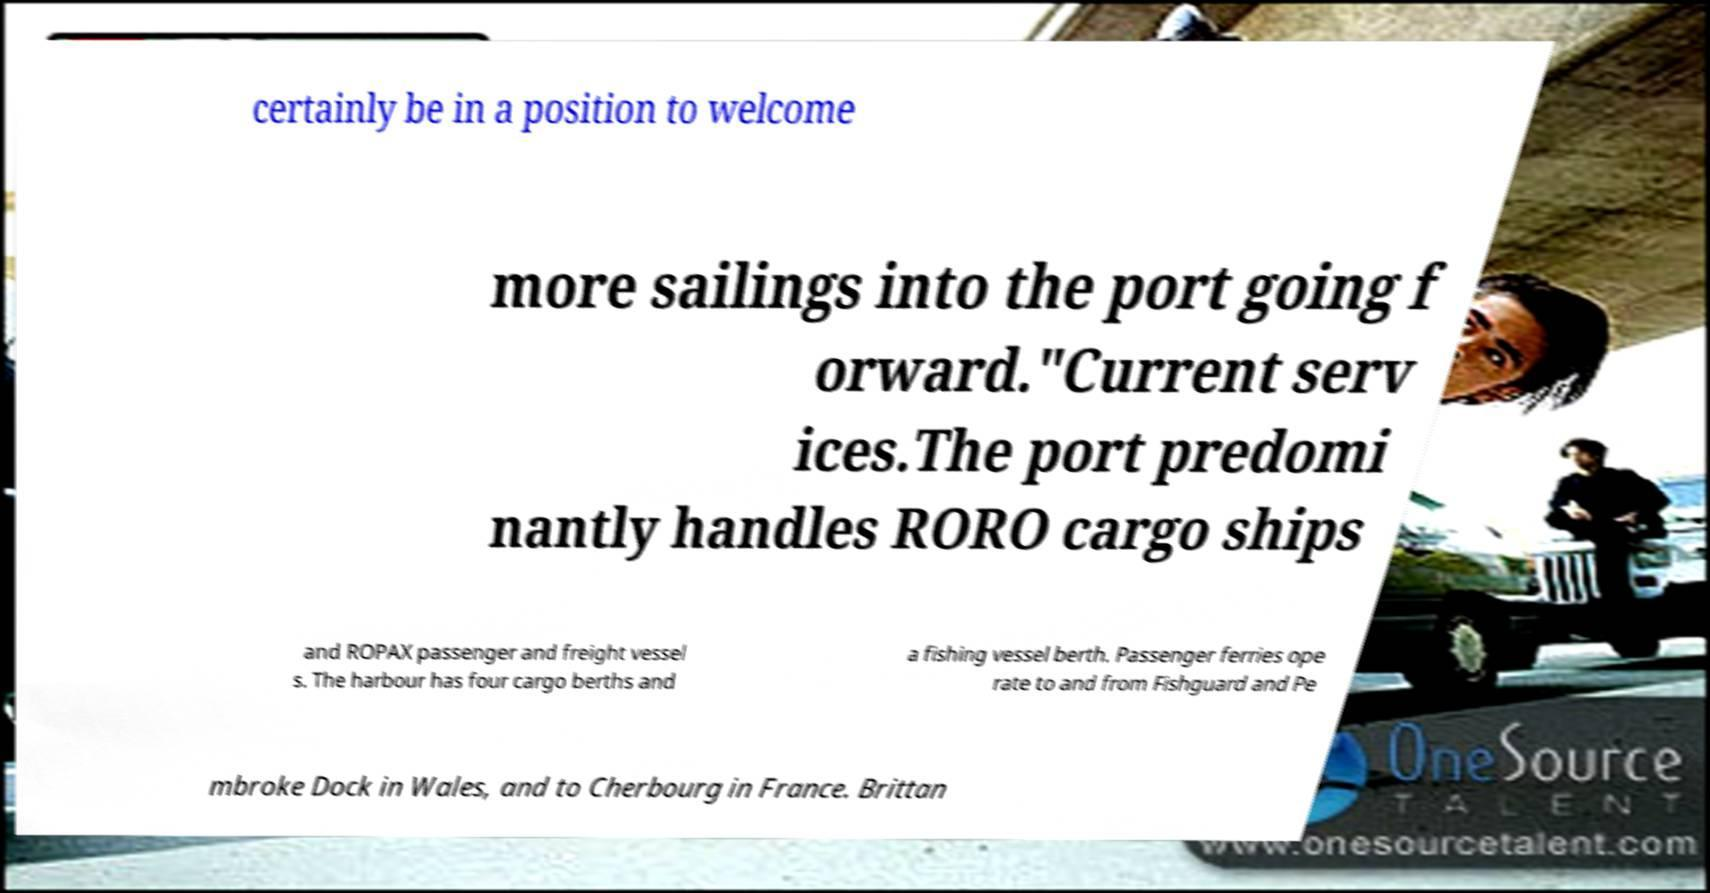Can you read and provide the text displayed in the image?This photo seems to have some interesting text. Can you extract and type it out for me? certainly be in a position to welcome more sailings into the port going f orward."Current serv ices.The port predomi nantly handles RORO cargo ships and ROPAX passenger and freight vessel s. The harbour has four cargo berths and a fishing vessel berth. Passenger ferries ope rate to and from Fishguard and Pe mbroke Dock in Wales, and to Cherbourg in France. Brittan 